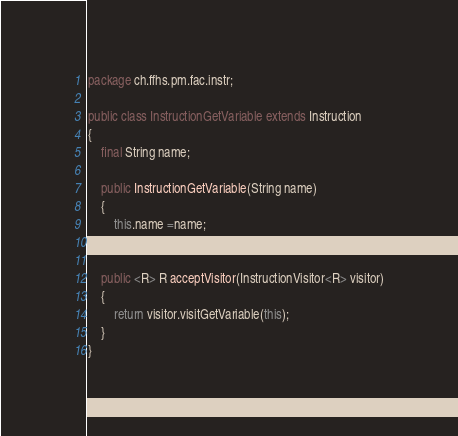Convert code to text. <code><loc_0><loc_0><loc_500><loc_500><_Java_>package ch.ffhs.pm.fac.instr;

public class InstructionGetVariable extends Instruction
{
    final String name;
    
    public InstructionGetVariable(String name)
    {
        this.name =name;
    }
    
    public <R> R acceptVisitor(InstructionVisitor<R> visitor)
    {
        return visitor.visitGetVariable(this);
    }
}
</code> 